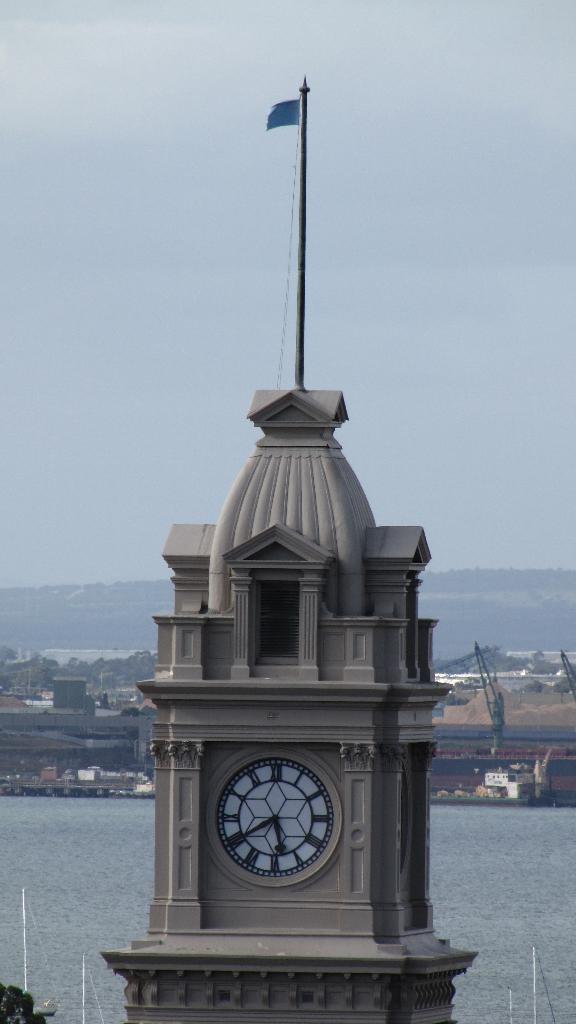What is the main structure in the image? There is a clock tower in the image. What is located at the bottom of the image? There is a sea at the bottom of the image. What can be seen in the background of the image? There are trees and mountains in the background of the image. What is visible at the top of the image? The sky is visible at the top of the image. What type of argument is taking place in the image? There is no argument present in the image; it features a clock tower, sea, trees, mountains, and sky. Can you see a basket in the image? There is no basket present in the image. 